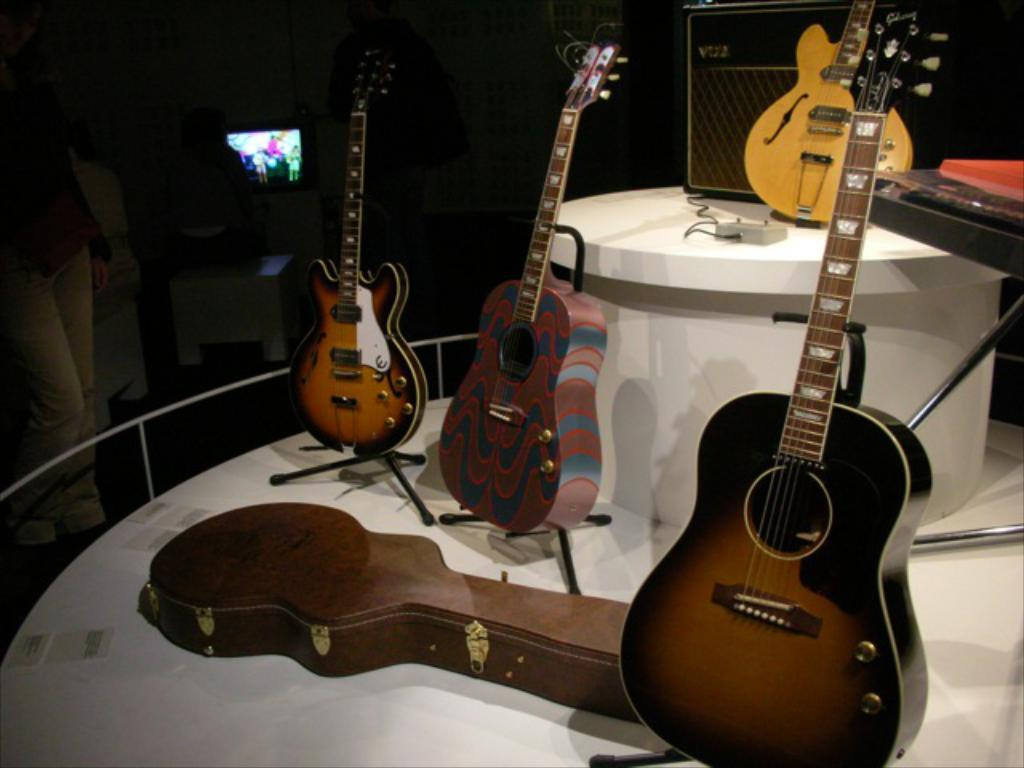How many pianos are visible in the image? There are four pianos in the image. What else related to pianos can be seen in the image? There is a piano box in the image. What type of table is present in the image? The white table is present in the image. What type of food is being served on the calendar in the image? There is no calendar or food present in the image; it only features four pianos, a piano box, and a white table. 